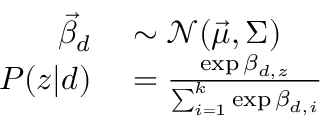<formula> <loc_0><loc_0><loc_500><loc_500>\begin{array} { r l } { \vec { \beta } _ { d } } & \sim \mathcal { N } ( \vec { \mu } , \Sigma ) } \\ { P ( z | d ) } & = \frac { \exp \beta _ { d , z } } { \sum _ { i = 1 } ^ { k } \exp \beta _ { d , i } } } \end{array}</formula> 